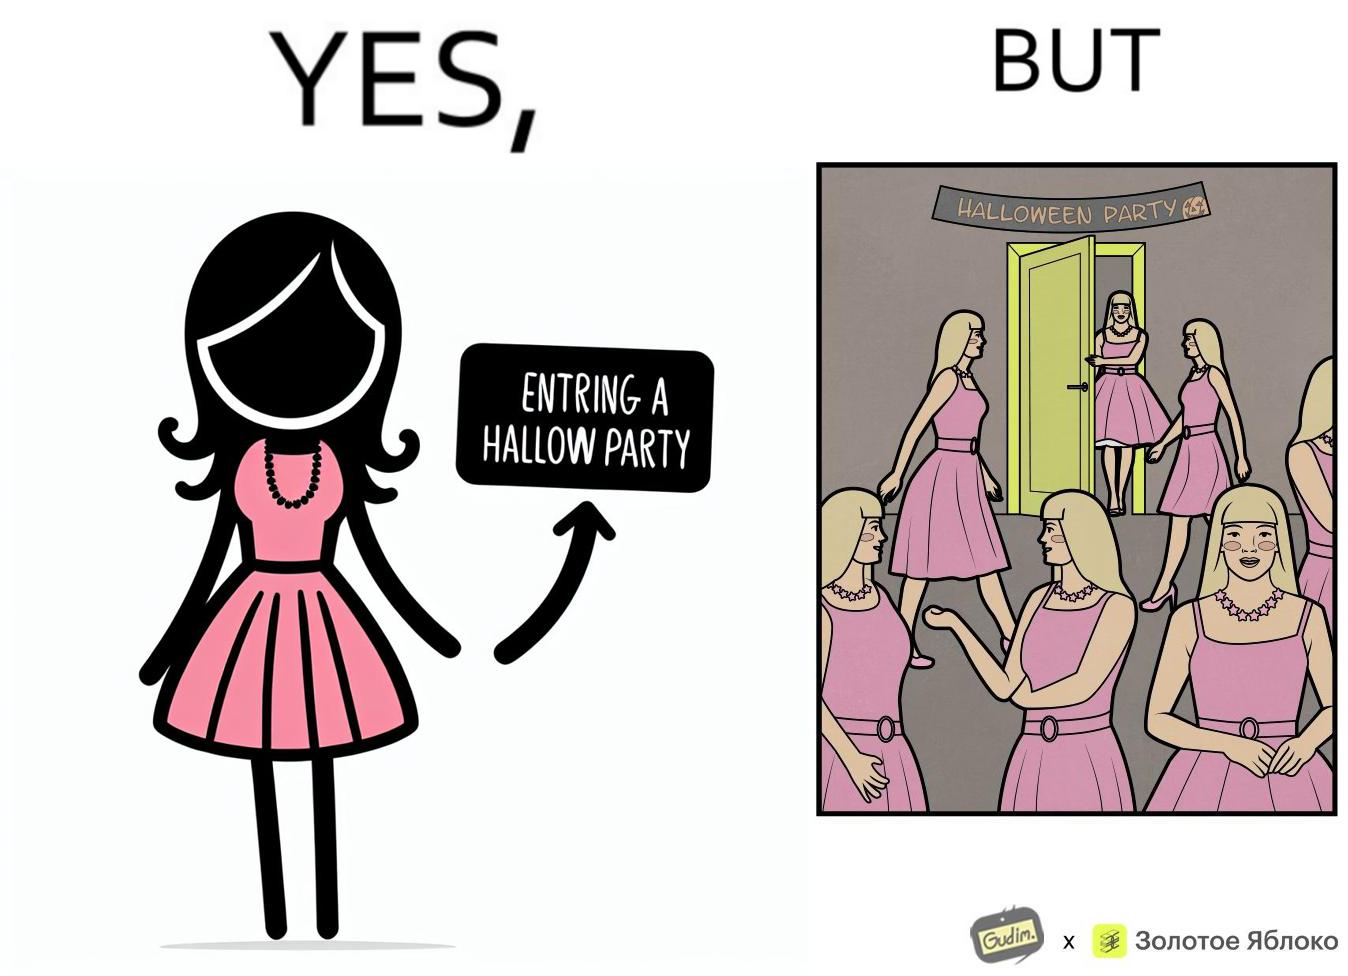Describe what you see in this image. The image is funny, as the person entering the Halloween Party has a costume that is identical to many other people in the party. 